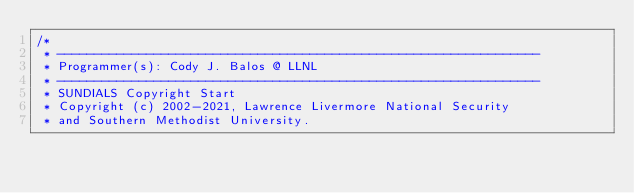<code> <loc_0><loc_0><loc_500><loc_500><_Cuda_>/*
 * -----------------------------------------------------------------
 * Programmer(s): Cody J. Balos @ LLNL
 * -----------------------------------------------------------------
 * SUNDIALS Copyright Start
 * Copyright (c) 2002-2021, Lawrence Livermore National Security
 * and Southern Methodist University.</code> 